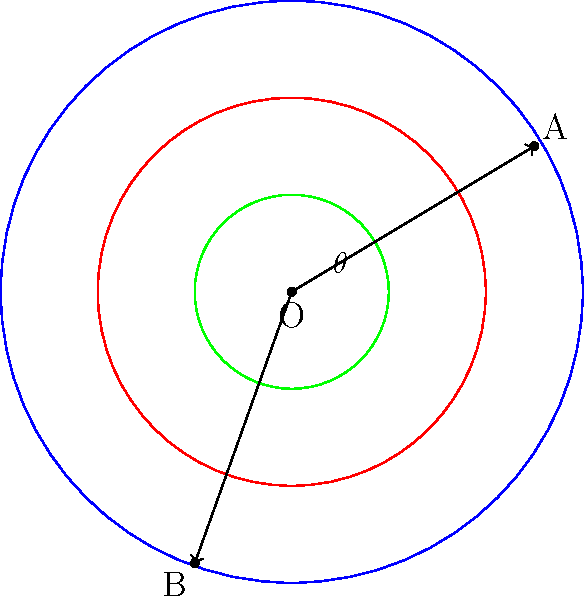In a curling house, two stones A and B are positioned as shown. The angle between them is $\theta$. If stone A is on the 4-foot circle (red) and stone B is on the 12-foot circle (blue), what is the measure of angle $\theta$ to the nearest degree? To solve this problem, we'll use the following steps:

1) First, we need to determine the coordinates of points A and B. From the diagram:
   A is approximately at (2.5, 1.5)
   B is approximately at (-1, -2.8)

2) We can calculate the angle using the dot product formula:
   $$\cos \theta = \frac{\vec{OA} \cdot \vec{OB}}{|\vec{OA}| |\vec{OB}|}$$

3) Calculate $\vec{OA}$ and $\vec{OB}$:
   $\vec{OA} = (2.5, 1.5)$
   $\vec{OB} = (-1, -2.8)$

4) Calculate the dot product $\vec{OA} \cdot \vec{OB}$:
   $\vec{OA} \cdot \vec{OB} = (2.5)(-1) + (1.5)(-2.8) = -2.5 - 4.2 = -6.7$

5) Calculate the magnitudes:
   $|\vec{OA}| = \sqrt{2.5^2 + 1.5^2} = \sqrt{8.5} \approx 2.92$
   $|\vec{OB}| = \sqrt{(-1)^2 + (-2.8)^2} = \sqrt{8.84} \approx 2.97$

6) Substitute into the formula:
   $$\cos \theta = \frac{-6.7}{(2.92)(2.97)} \approx -0.7721$$

7) Take the inverse cosine (arccos) of both sides:
   $$\theta = \arccos(-0.7721) \approx 2.5307 \text{ radians}$$

8) Convert to degrees:
   $$\theta \approx 2.5307 \times \frac{180}{\pi} \approx 145.0°$$

9) Rounding to the nearest degree:
   $$\theta \approx 145°$$
Answer: 145° 